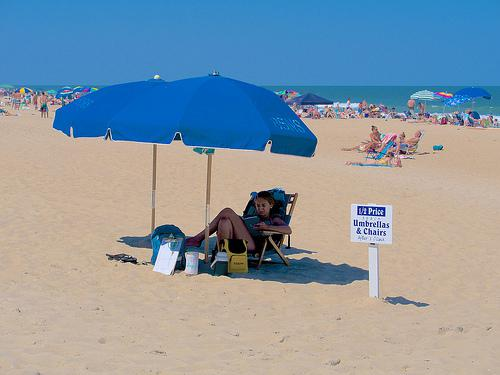Question: how many people are reading that are not blurry?
Choices:
A. Two.
B. Three.
C. One.
D. Four.
Answer with the letter. Answer: C Question: what color is the sign?
Choices:
A. Red.
B. White and blue.
C. Green.
D. Black.
Answer with the letter. Answer: B Question: what color is the girls umbrella?
Choices:
A. Red.
B. Green.
C. White.
D. Blue.
Answer with the letter. Answer: D Question: where is this picture taken?
Choices:
A. Beach.
B. Home.
C. Tampa.
D. Outside.
Answer with the letter. Answer: A 